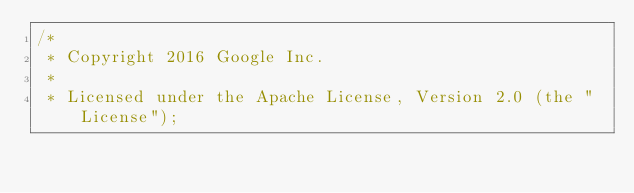<code> <loc_0><loc_0><loc_500><loc_500><_Java_>/*
 * Copyright 2016 Google Inc.
 *
 * Licensed under the Apache License, Version 2.0 (the "License");</code> 